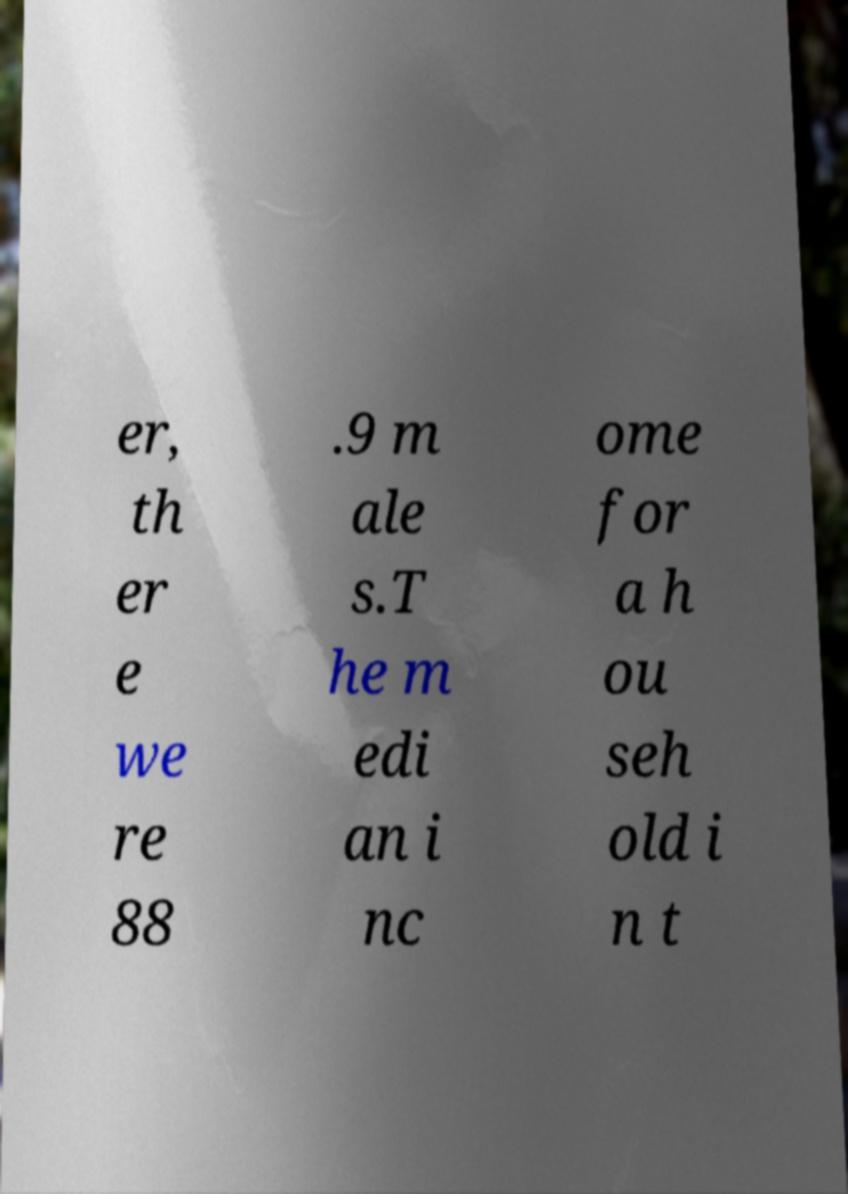Can you read and provide the text displayed in the image?This photo seems to have some interesting text. Can you extract and type it out for me? er, th er e we re 88 .9 m ale s.T he m edi an i nc ome for a h ou seh old i n t 